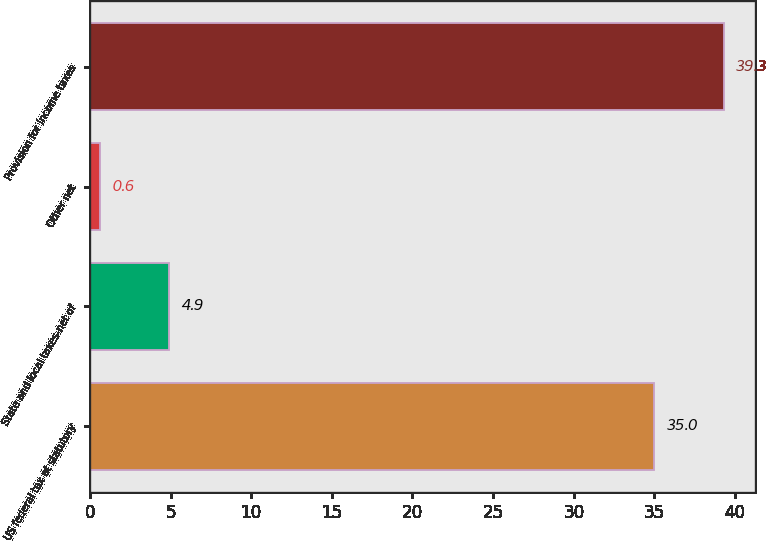<chart> <loc_0><loc_0><loc_500><loc_500><bar_chart><fcel>US federal tax at statutory<fcel>State and local taxes-net of<fcel>Other net<fcel>Provision for income taxes<nl><fcel>35<fcel>4.9<fcel>0.6<fcel>39.3<nl></chart> 